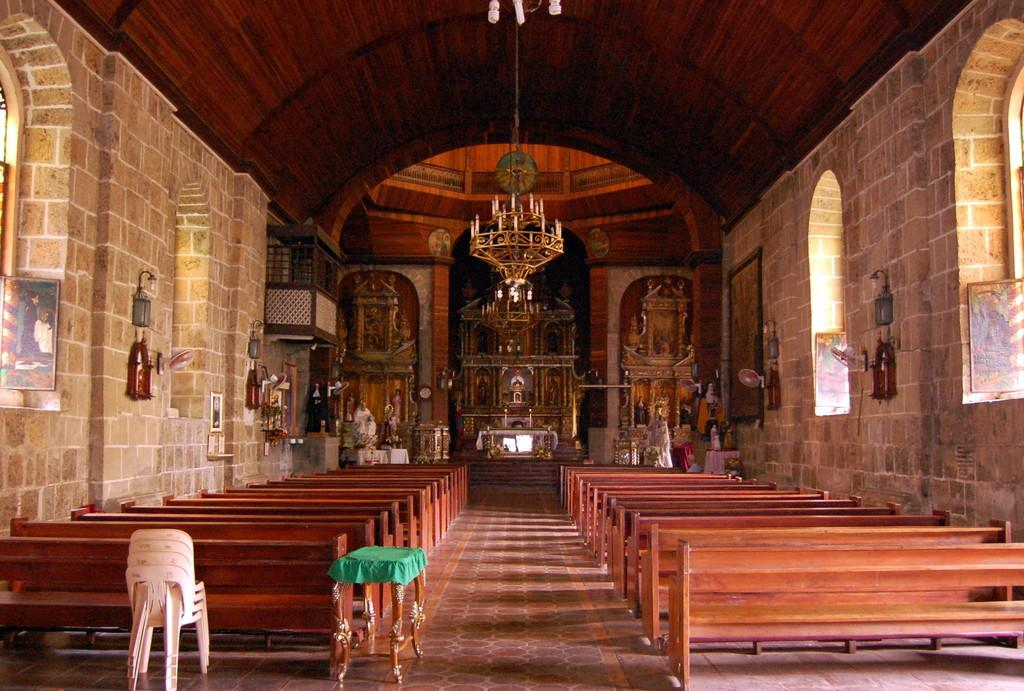What type of furniture can be seen in the image? There are chairs, a stool, and benches in the image. What type of lighting is present in the image? There is a chandelier light in the image. What type of decorative items are present in the image? There are statues and photo frames in the image. What can be seen in the background of the image? There is a wall, a roof, windows, and some unspecified objects in the background of the image. How many fowl are perched on the chandelier in the image? There are no fowl present in the image. What type of operation is being performed on the statue in the image? There is no operation being performed on the statue in the image; it is a decorative item. 